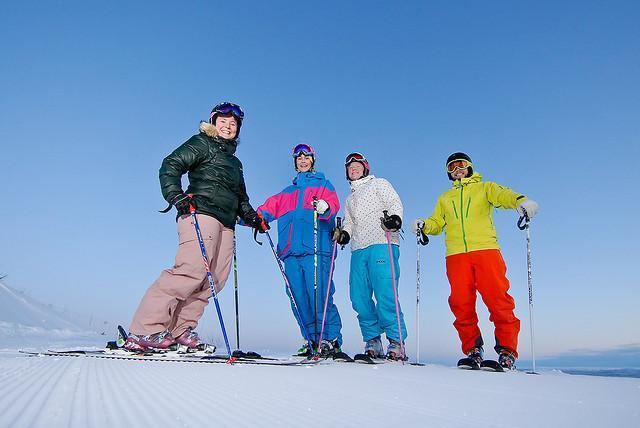How many skies are there?
Give a very brief answer. 8. How many people are in the photo?
Give a very brief answer. 4. How many people are there?
Give a very brief answer. 4. How many blue airplanes are in the image?
Give a very brief answer. 0. 